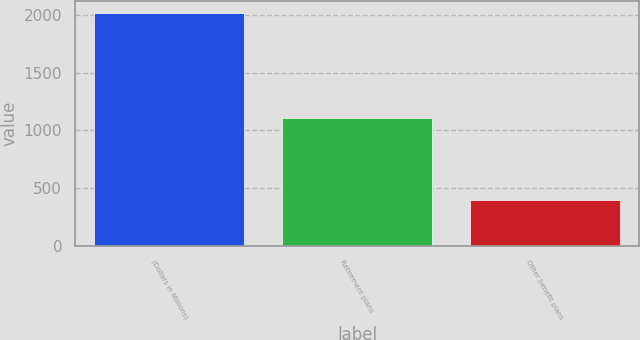<chart> <loc_0><loc_0><loc_500><loc_500><bar_chart><fcel>(Dollars in Millions)<fcel>Retirement plans<fcel>Other benefit plans<nl><fcel>2020<fcel>1104<fcel>397<nl></chart> 